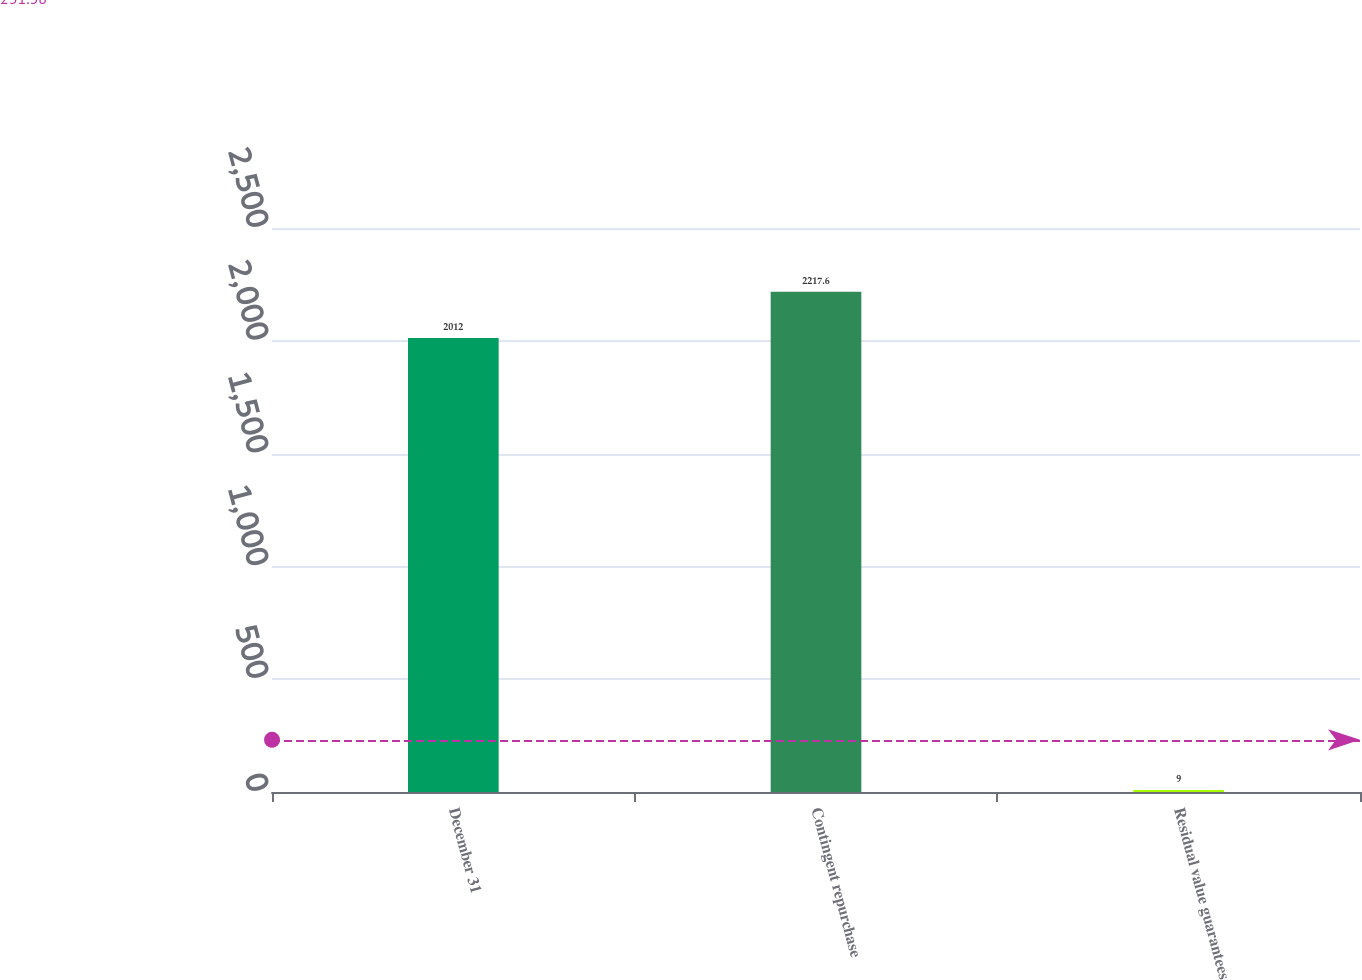Convert chart. <chart><loc_0><loc_0><loc_500><loc_500><bar_chart><fcel>December 31<fcel>Contingent repurchase<fcel>Residual value guarantees<nl><fcel>2012<fcel>2217.6<fcel>9<nl></chart> 